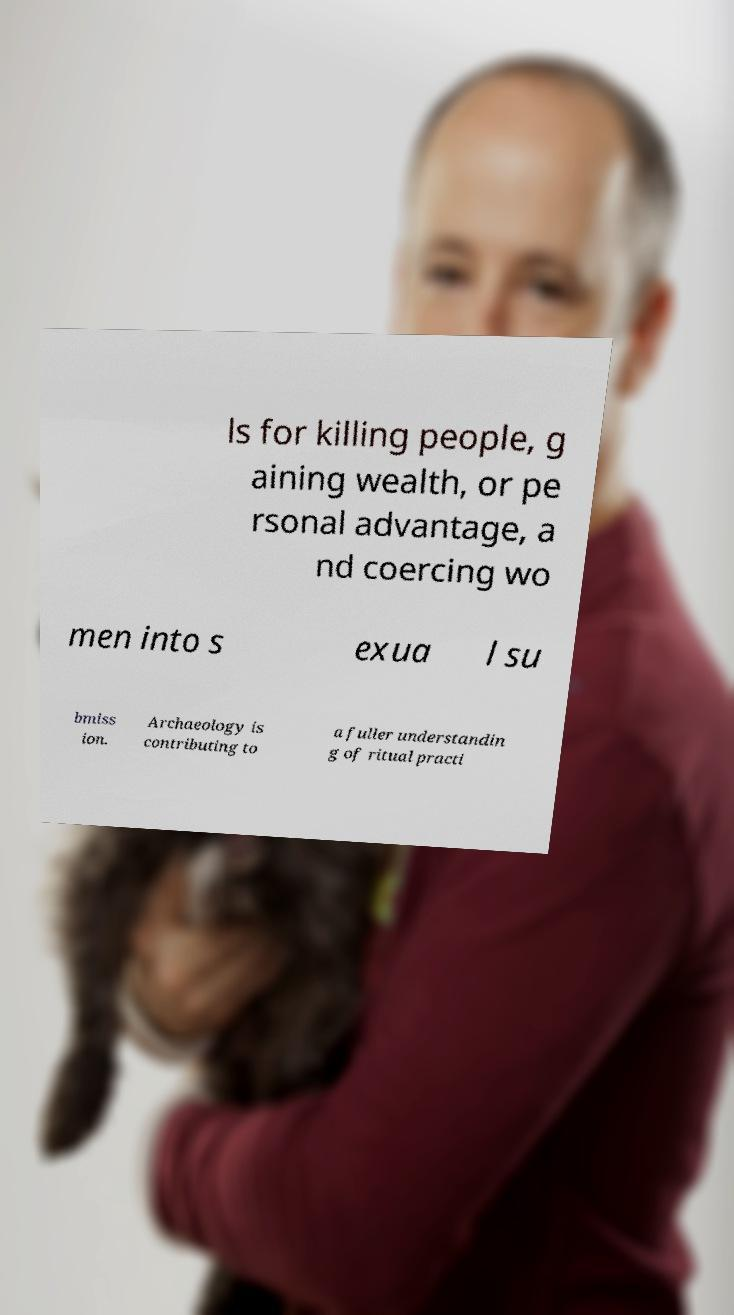What messages or text are displayed in this image? I need them in a readable, typed format. ls for killing people, g aining wealth, or pe rsonal advantage, a nd coercing wo men into s exua l su bmiss ion. Archaeology is contributing to a fuller understandin g of ritual practi 